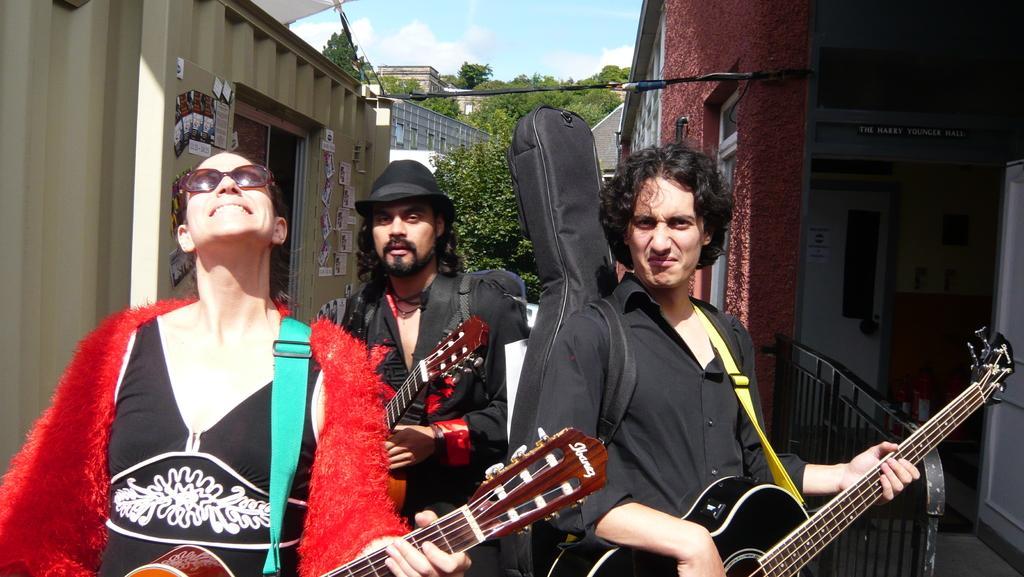Describe this image in one or two sentences. At the top of the picture we can see sky with cloud. In the background we can see buildings, trees. Here we can see three persons standing and playing guitar. This is a door. 